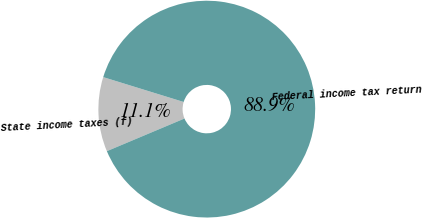<chart> <loc_0><loc_0><loc_500><loc_500><pie_chart><fcel>State income taxes (f)<fcel>Federal income tax return<nl><fcel>11.11%<fcel>88.89%<nl></chart> 